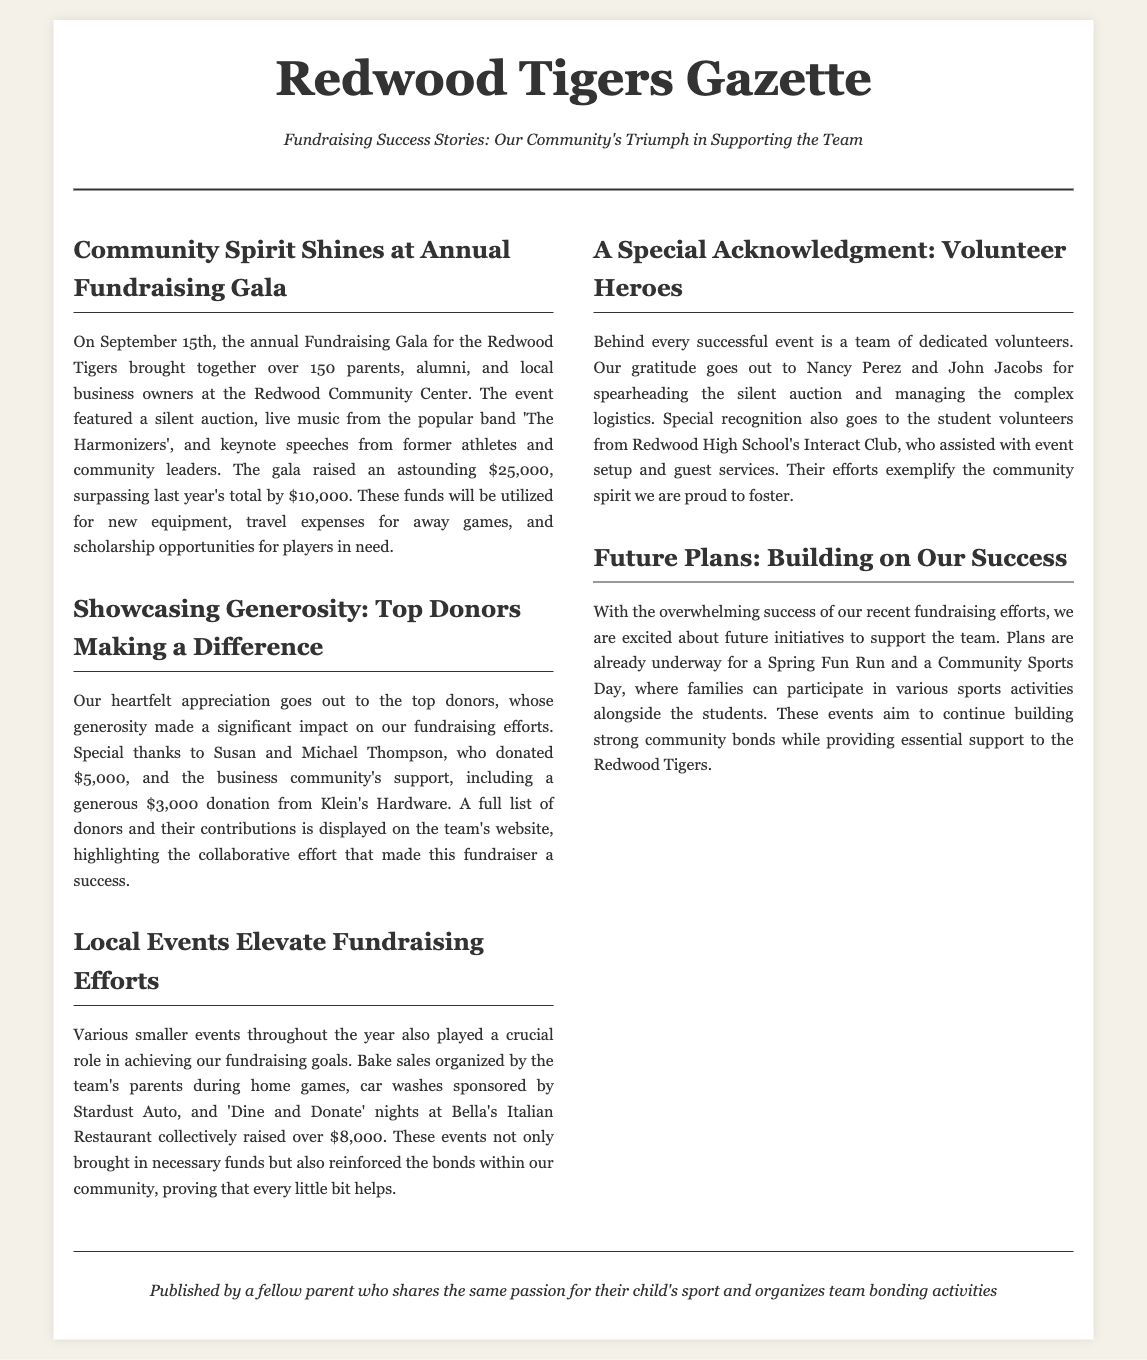What was the date of the annual Fundraising Gala? The document specifies that the annual Fundraising Gala took place on September 15th.
Answer: September 15th How much money was raised at the gala? The document states that the gala raised an astounding amount of $25,000.
Answer: $25,000 Who were the top donors acknowledged in the article? The document mentions Susan and Michael Thompson as the top donors.
Answer: Susan and Michael Thompson What was one community event that contributed to the fundraising? The article lists bake sales organized during home games as one contributing event.
Answer: Bake sales What are two future events planned to support the team? The document outlines plans for a Spring Fun Run and a Community Sports Day.
Answer: Spring Fun Run and Community Sports Day How much did Klein's Hardware donate? The document indicates that Klein's Hardware made a donation of $3,000.
Answer: $3,000 Who managed the silent auction? The article highlights Nancy Perez and John Jacobs as those who spearheaded the silent auction.
Answer: Nancy Perez and John Jacobs What is the theme of the newspaper article? The overarching theme of the article revolves around fundraising success stories.
Answer: Fundraising success stories What type of entertainment was featured at the gala? The document notes that live music from 'The Harmonizers' was a part of the gala.
Answer: Live music from 'The Harmonizers' 